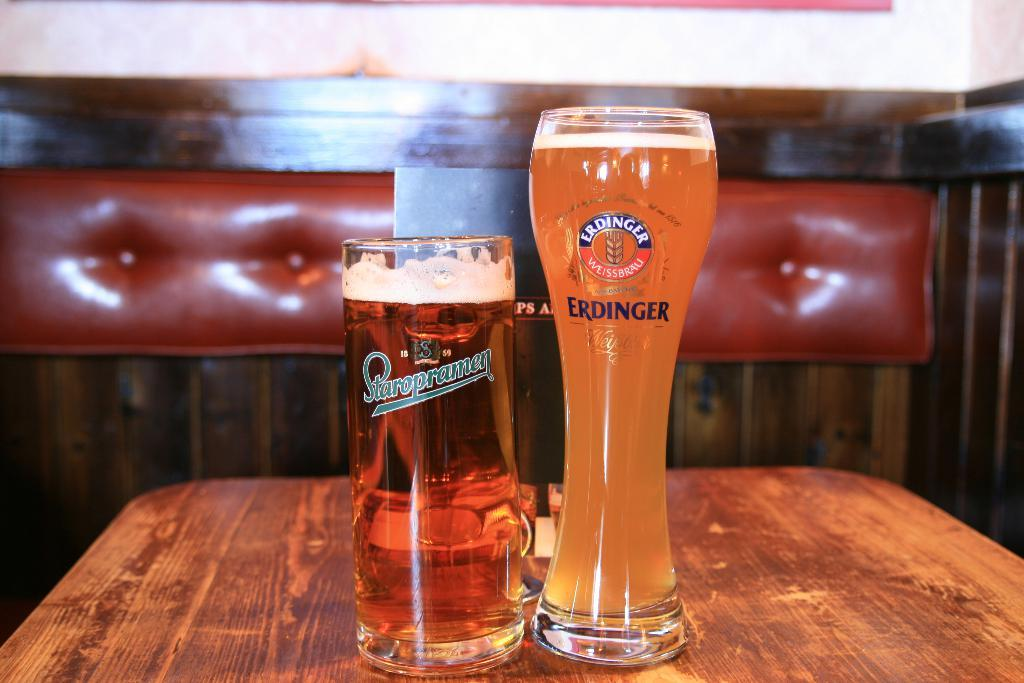<image>
Relay a brief, clear account of the picture shown. a glass that says 'erdinger weissbrau erdinger' on it sitting on a counter 